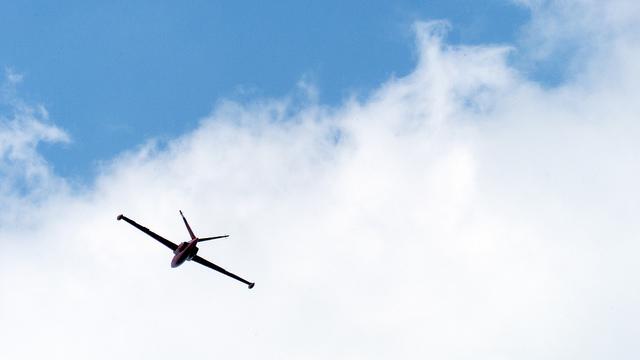Are there birds flying?
Write a very short answer. No. How many planes are in the air?
Concise answer only. 1. How many planes do you see?
Give a very brief answer. 1. Is the airplane's landing gear up or down?
Quick response, please. Up. How many planes are there?
Be succinct. 1. Can you see the moon?
Give a very brief answer. No. Is it a cloudy day?
Keep it brief. Yes. 